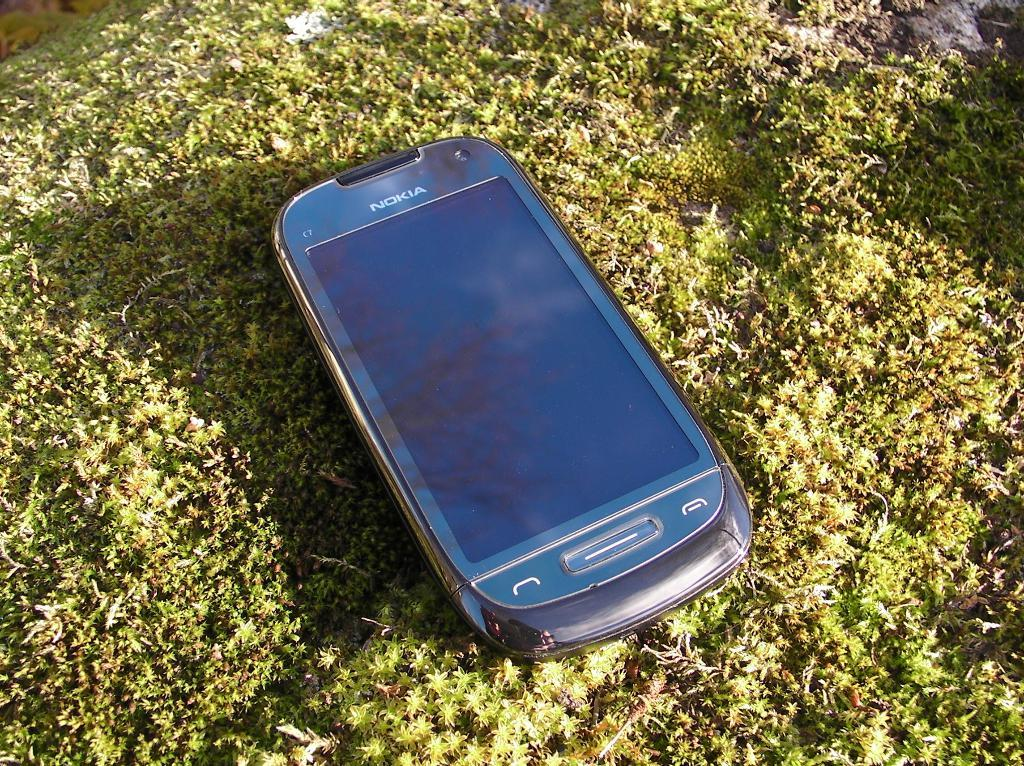<image>
Summarize the visual content of the image. A Nokia smart electronic device laying in a bunch of grass. 